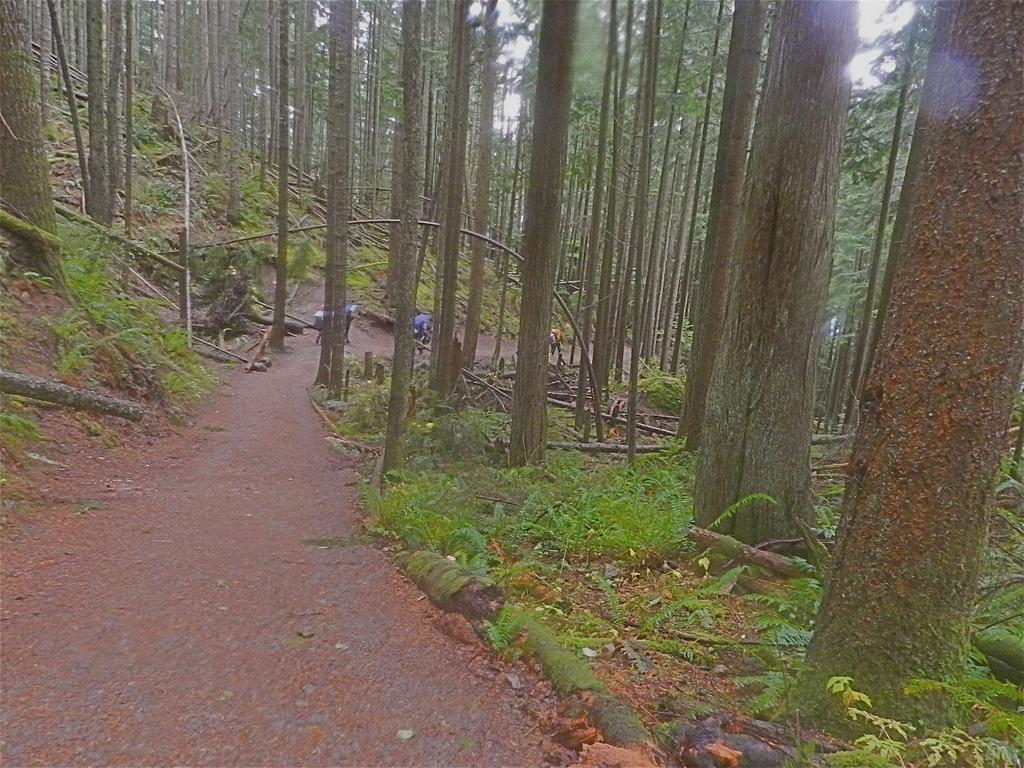In one or two sentences, can you explain what this image depicts? In this picture I can see few persons standing. There are trees, plants, and in the background there is the sky. 